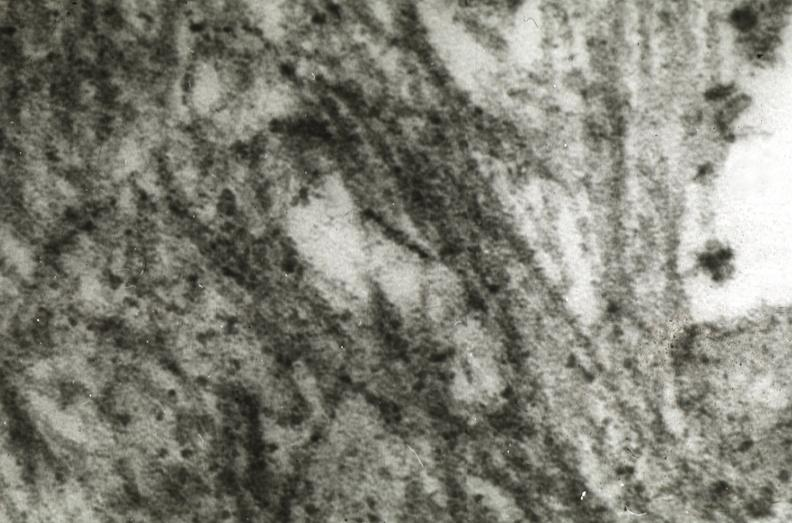s cardiovascular present?
Answer the question using a single word or phrase. Yes 